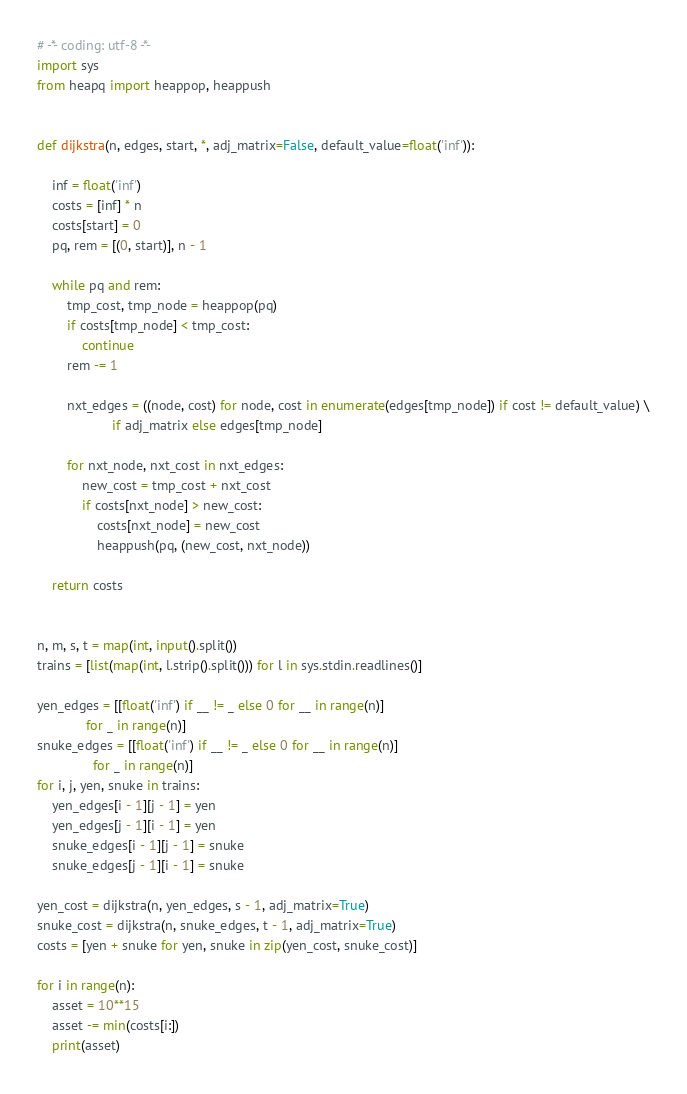Convert code to text. <code><loc_0><loc_0><loc_500><loc_500><_Python_># -*- coding: utf-8 -*-
import sys
from heapq import heappop, heappush


def dijkstra(n, edges, start, *, adj_matrix=False, default_value=float('inf')):

    inf = float('inf')
    costs = [inf] * n
    costs[start] = 0
    pq, rem = [(0, start)], n - 1

    while pq and rem:
        tmp_cost, tmp_node = heappop(pq)
        if costs[tmp_node] < tmp_cost:
            continue
        rem -= 1

        nxt_edges = ((node, cost) for node, cost in enumerate(edges[tmp_node]) if cost != default_value) \
                    if adj_matrix else edges[tmp_node]

        for nxt_node, nxt_cost in nxt_edges:
            new_cost = tmp_cost + nxt_cost
            if costs[nxt_node] > new_cost:
                costs[nxt_node] = new_cost
                heappush(pq, (new_cost, nxt_node))

    return costs


n, m, s, t = map(int, input().split())
trains = [list(map(int, l.strip().split())) for l in sys.stdin.readlines()]

yen_edges = [[float('inf') if __ != _ else 0 for __ in range(n)]
             for _ in range(n)]
snuke_edges = [[float('inf') if __ != _ else 0 for __ in range(n)]
               for _ in range(n)]
for i, j, yen, snuke in trains:
    yen_edges[i - 1][j - 1] = yen
    yen_edges[j - 1][i - 1] = yen
    snuke_edges[i - 1][j - 1] = snuke
    snuke_edges[j - 1][i - 1] = snuke

yen_cost = dijkstra(n, yen_edges, s - 1, adj_matrix=True)
snuke_cost = dijkstra(n, snuke_edges, t - 1, adj_matrix=True)
costs = [yen + snuke for yen, snuke in zip(yen_cost, snuke_cost)]

for i in range(n):
    asset = 10**15
    asset -= min(costs[i:])
    print(asset)
</code> 